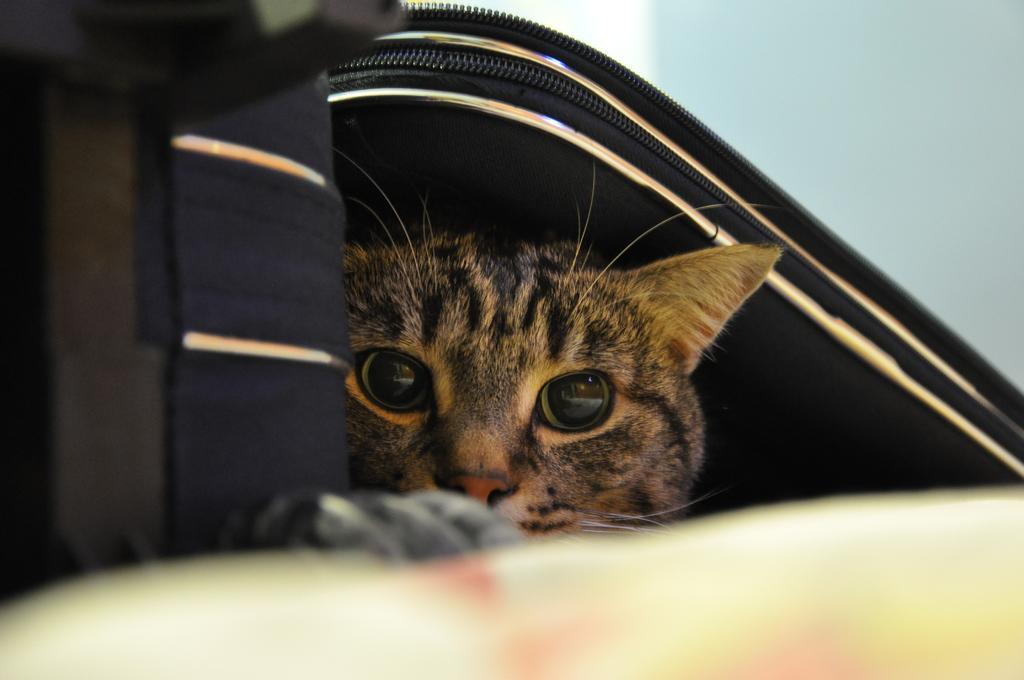In one or two sentences, can you explain what this image depicts? In the picture we can see a bag with a zip under it we can see a cat and behind the bag we can see a wall. 